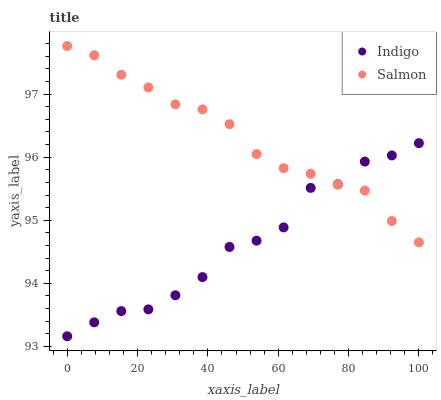Does Indigo have the minimum area under the curve?
Answer yes or no. Yes. Does Salmon have the maximum area under the curve?
Answer yes or no. Yes. Does Indigo have the maximum area under the curve?
Answer yes or no. No. Is Salmon the smoothest?
Answer yes or no. Yes. Is Indigo the roughest?
Answer yes or no. Yes. Is Indigo the smoothest?
Answer yes or no. No. Does Indigo have the lowest value?
Answer yes or no. Yes. Does Salmon have the highest value?
Answer yes or no. Yes. Does Indigo have the highest value?
Answer yes or no. No. Does Indigo intersect Salmon?
Answer yes or no. Yes. Is Indigo less than Salmon?
Answer yes or no. No. Is Indigo greater than Salmon?
Answer yes or no. No. 